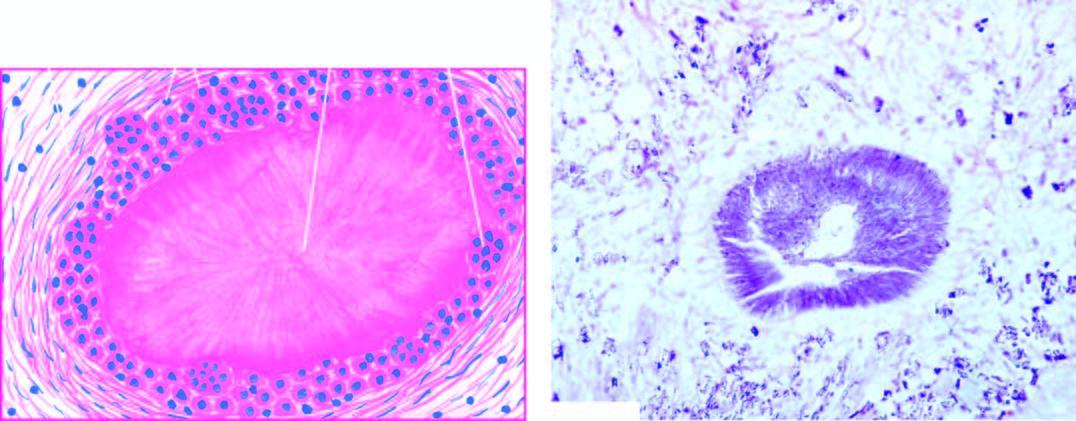s gouty tophus, showing central aggregates of urate crystals surrounded by inflammatory cells, fibroblasts and occasional giant cells?
Answer the question using a single word or phrase. No 